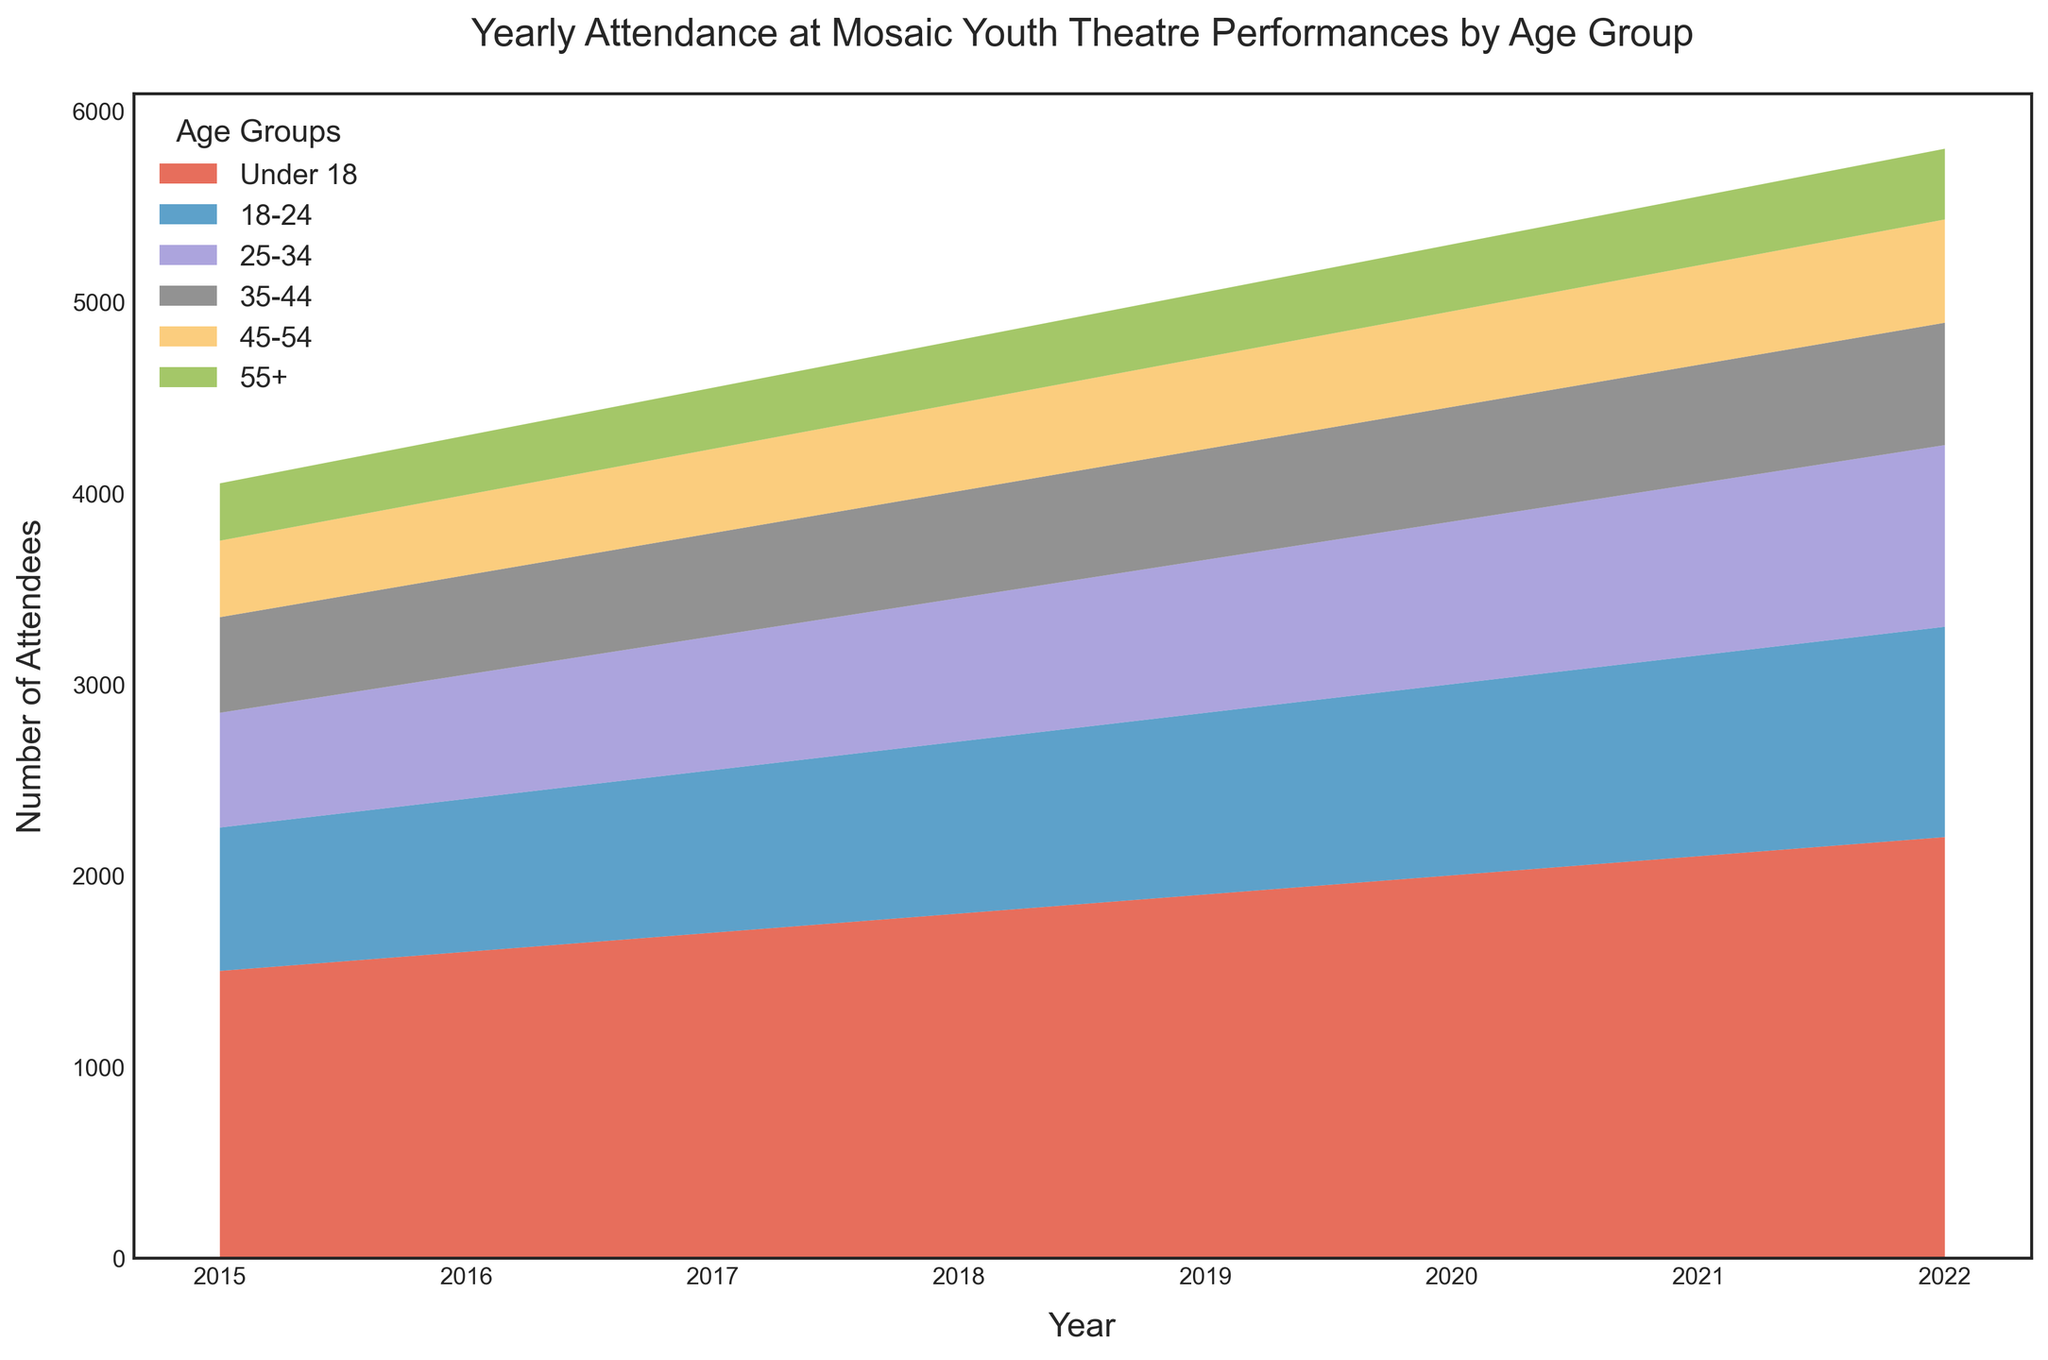How does the attendance of Under 18 compare to the 55+ age group in 2022? To determine this, look at the values for both age groups in 2022. The Under 18 group has 2200 attendees, and the 55+ group has 370 attendees.
Answer: Under 18 has more attendees What is the total number of attendees in all age groups for the year 2020? Sum the values of all age groups for 2020: 2000 (Under 18) + 1000 (18-24) + 850 (25-34) + 600 (35-44) + 500 (45-54) + 350 (55+).
Answer: 5300 